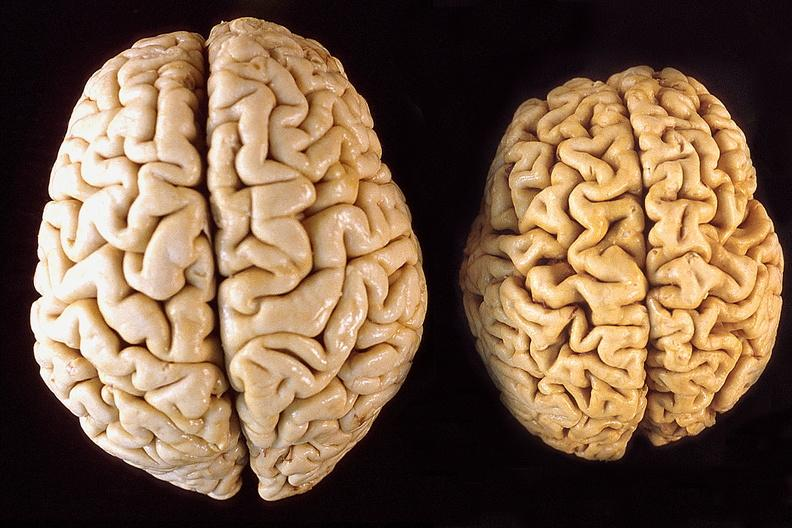does polyarteritis nodosa show brain, atrophy compared to normal?
Answer the question using a single word or phrase. No 